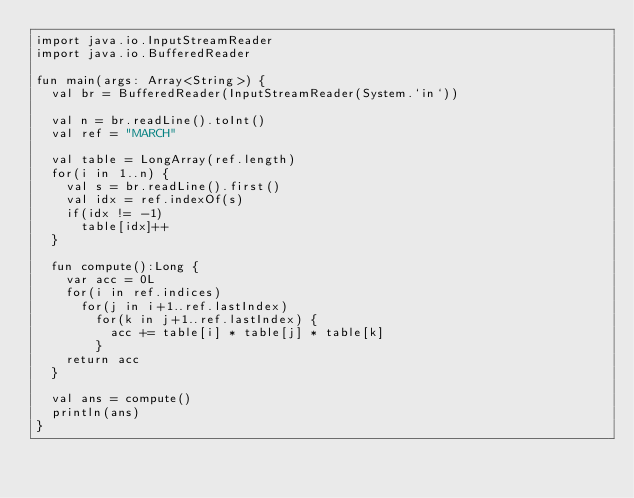Convert code to text. <code><loc_0><loc_0><loc_500><loc_500><_Kotlin_>import java.io.InputStreamReader
import java.io.BufferedReader

fun main(args: Array<String>) {
  val br = BufferedReader(InputStreamReader(System.`in`))

  val n = br.readLine().toInt()
  val ref = "MARCH"

  val table = LongArray(ref.length)
  for(i in 1..n) {
    val s = br.readLine().first()
    val idx = ref.indexOf(s)
    if(idx != -1)
      table[idx]++
  }

  fun compute():Long {
    var acc = 0L
    for(i in ref.indices)
      for(j in i+1..ref.lastIndex)
        for(k in j+1..ref.lastIndex) {
          acc += table[i] * table[j] * table[k]
        }
    return acc
  }

  val ans = compute()
  println(ans)
}</code> 